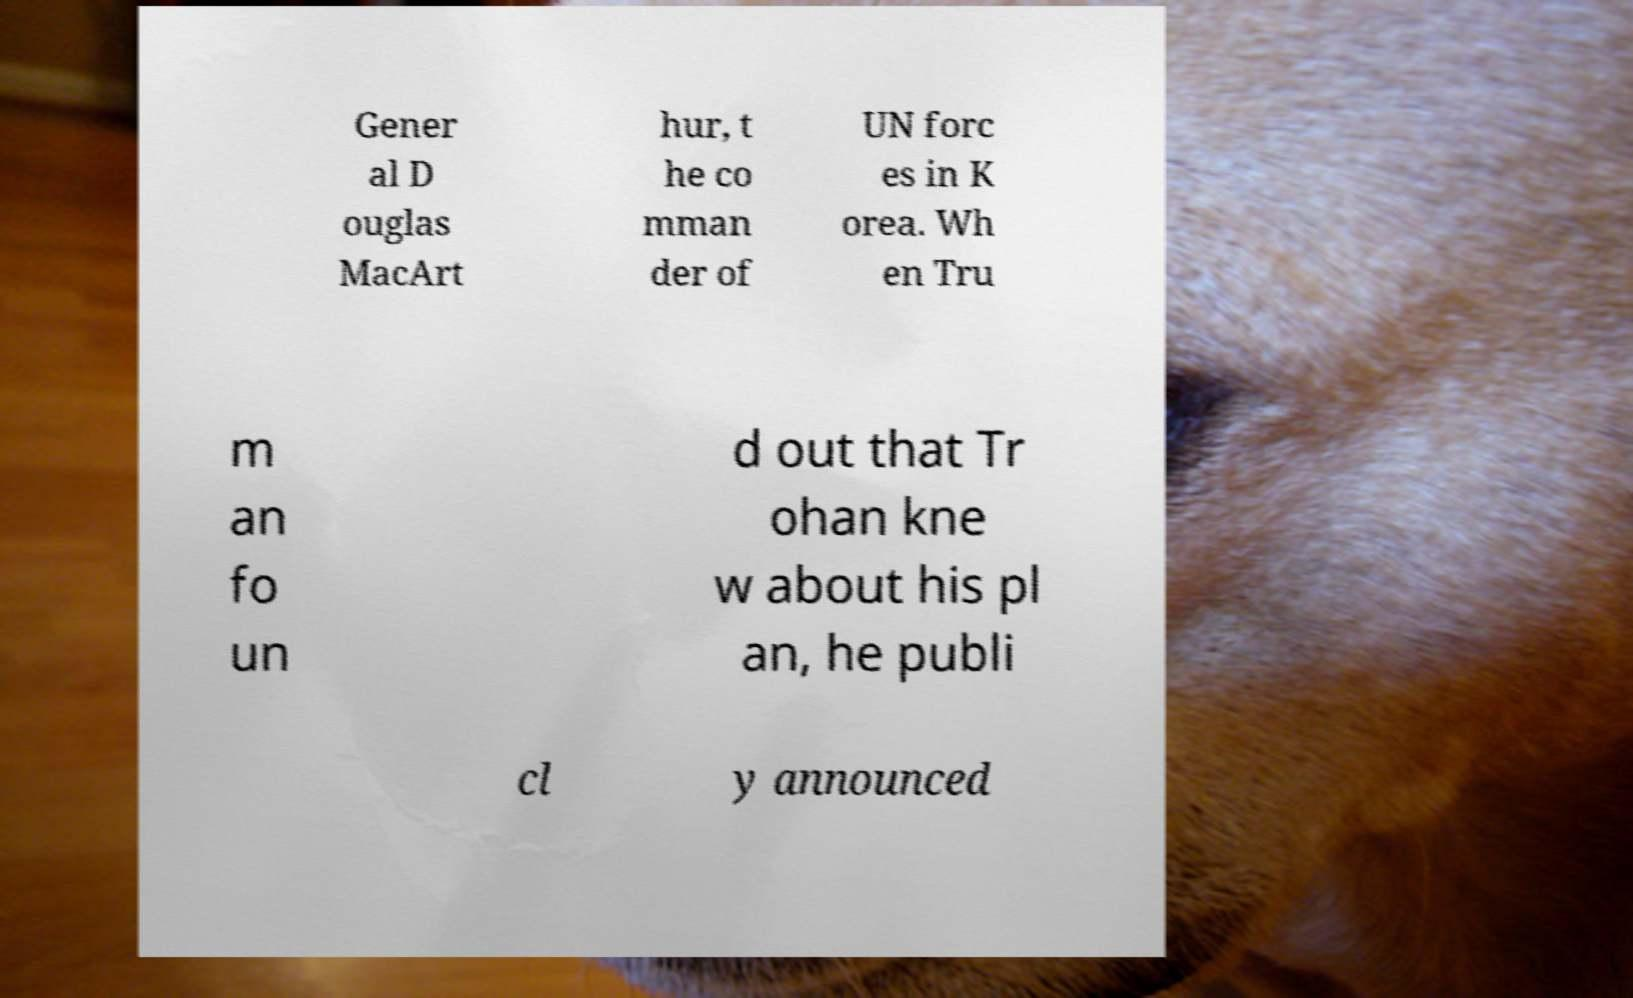Can you accurately transcribe the text from the provided image for me? Gener al D ouglas MacArt hur, t he co mman der of UN forc es in K orea. Wh en Tru m an fo un d out that Tr ohan kne w about his pl an, he publi cl y announced 